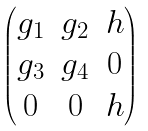<formula> <loc_0><loc_0><loc_500><loc_500>\begin{pmatrix} g _ { 1 } & g _ { 2 } & h \\ g _ { 3 } & g _ { 4 } & 0 \\ 0 & 0 & h \end{pmatrix}</formula> 